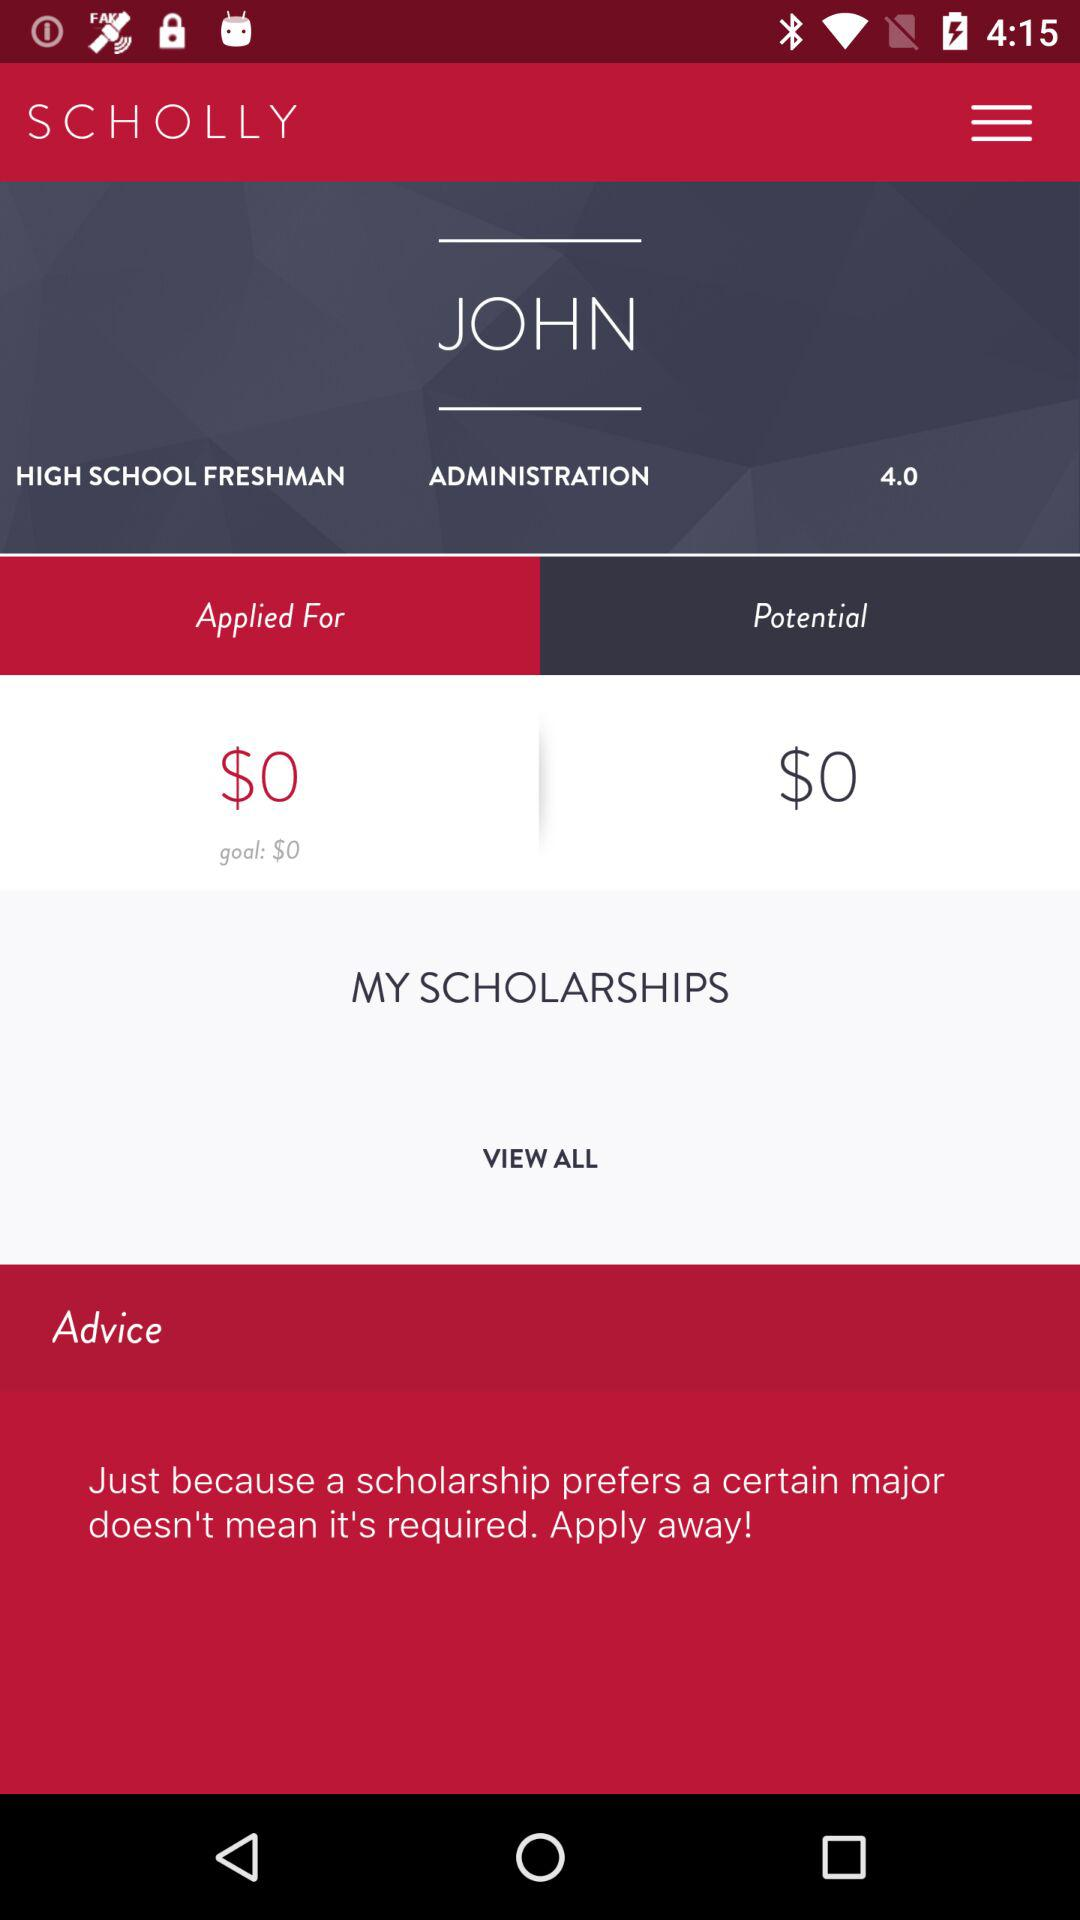What is the name? The name is John. 